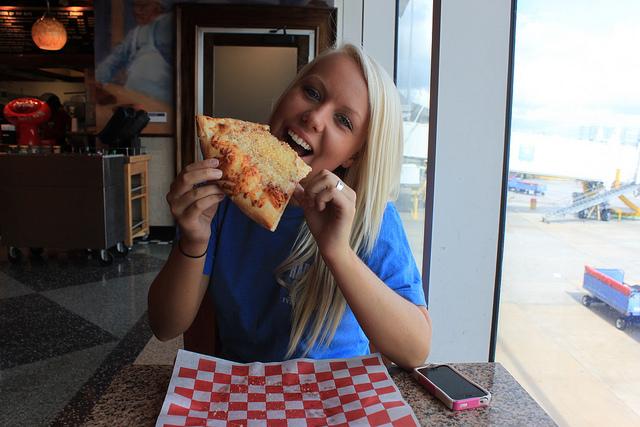Is there someone behind the female?
Quick response, please. No. What is on the table near the girl's left elbow?
Give a very brief answer. Phone. Is anyone wearing glasses?
Be succinct. No. Does she have both of her elbows on the table?
Be succinct. No. What is the girl eating in the picture?
Answer briefly. Pizza. 